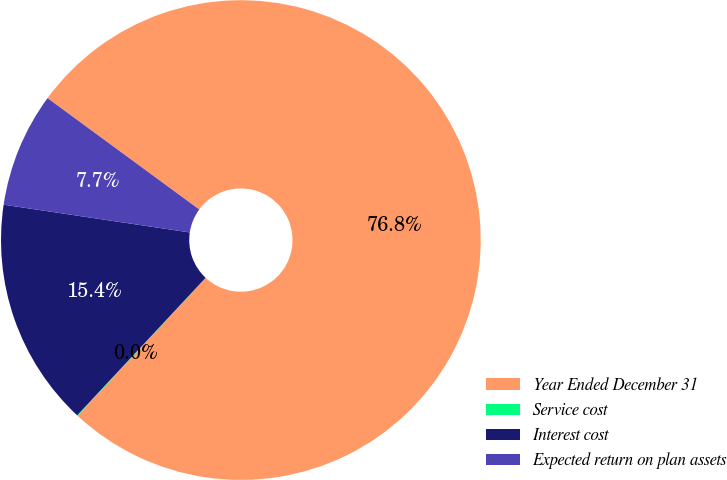Convert chart. <chart><loc_0><loc_0><loc_500><loc_500><pie_chart><fcel>Year Ended December 31<fcel>Service cost<fcel>Interest cost<fcel>Expected return on plan assets<nl><fcel>76.84%<fcel>0.04%<fcel>15.4%<fcel>7.72%<nl></chart> 